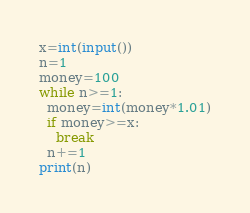<code> <loc_0><loc_0><loc_500><loc_500><_Python_>x=int(input())
n=1
money=100
while n>=1:
  money=int(money*1.01)
  if money>=x:
    break
  n+=1
print(n)</code> 